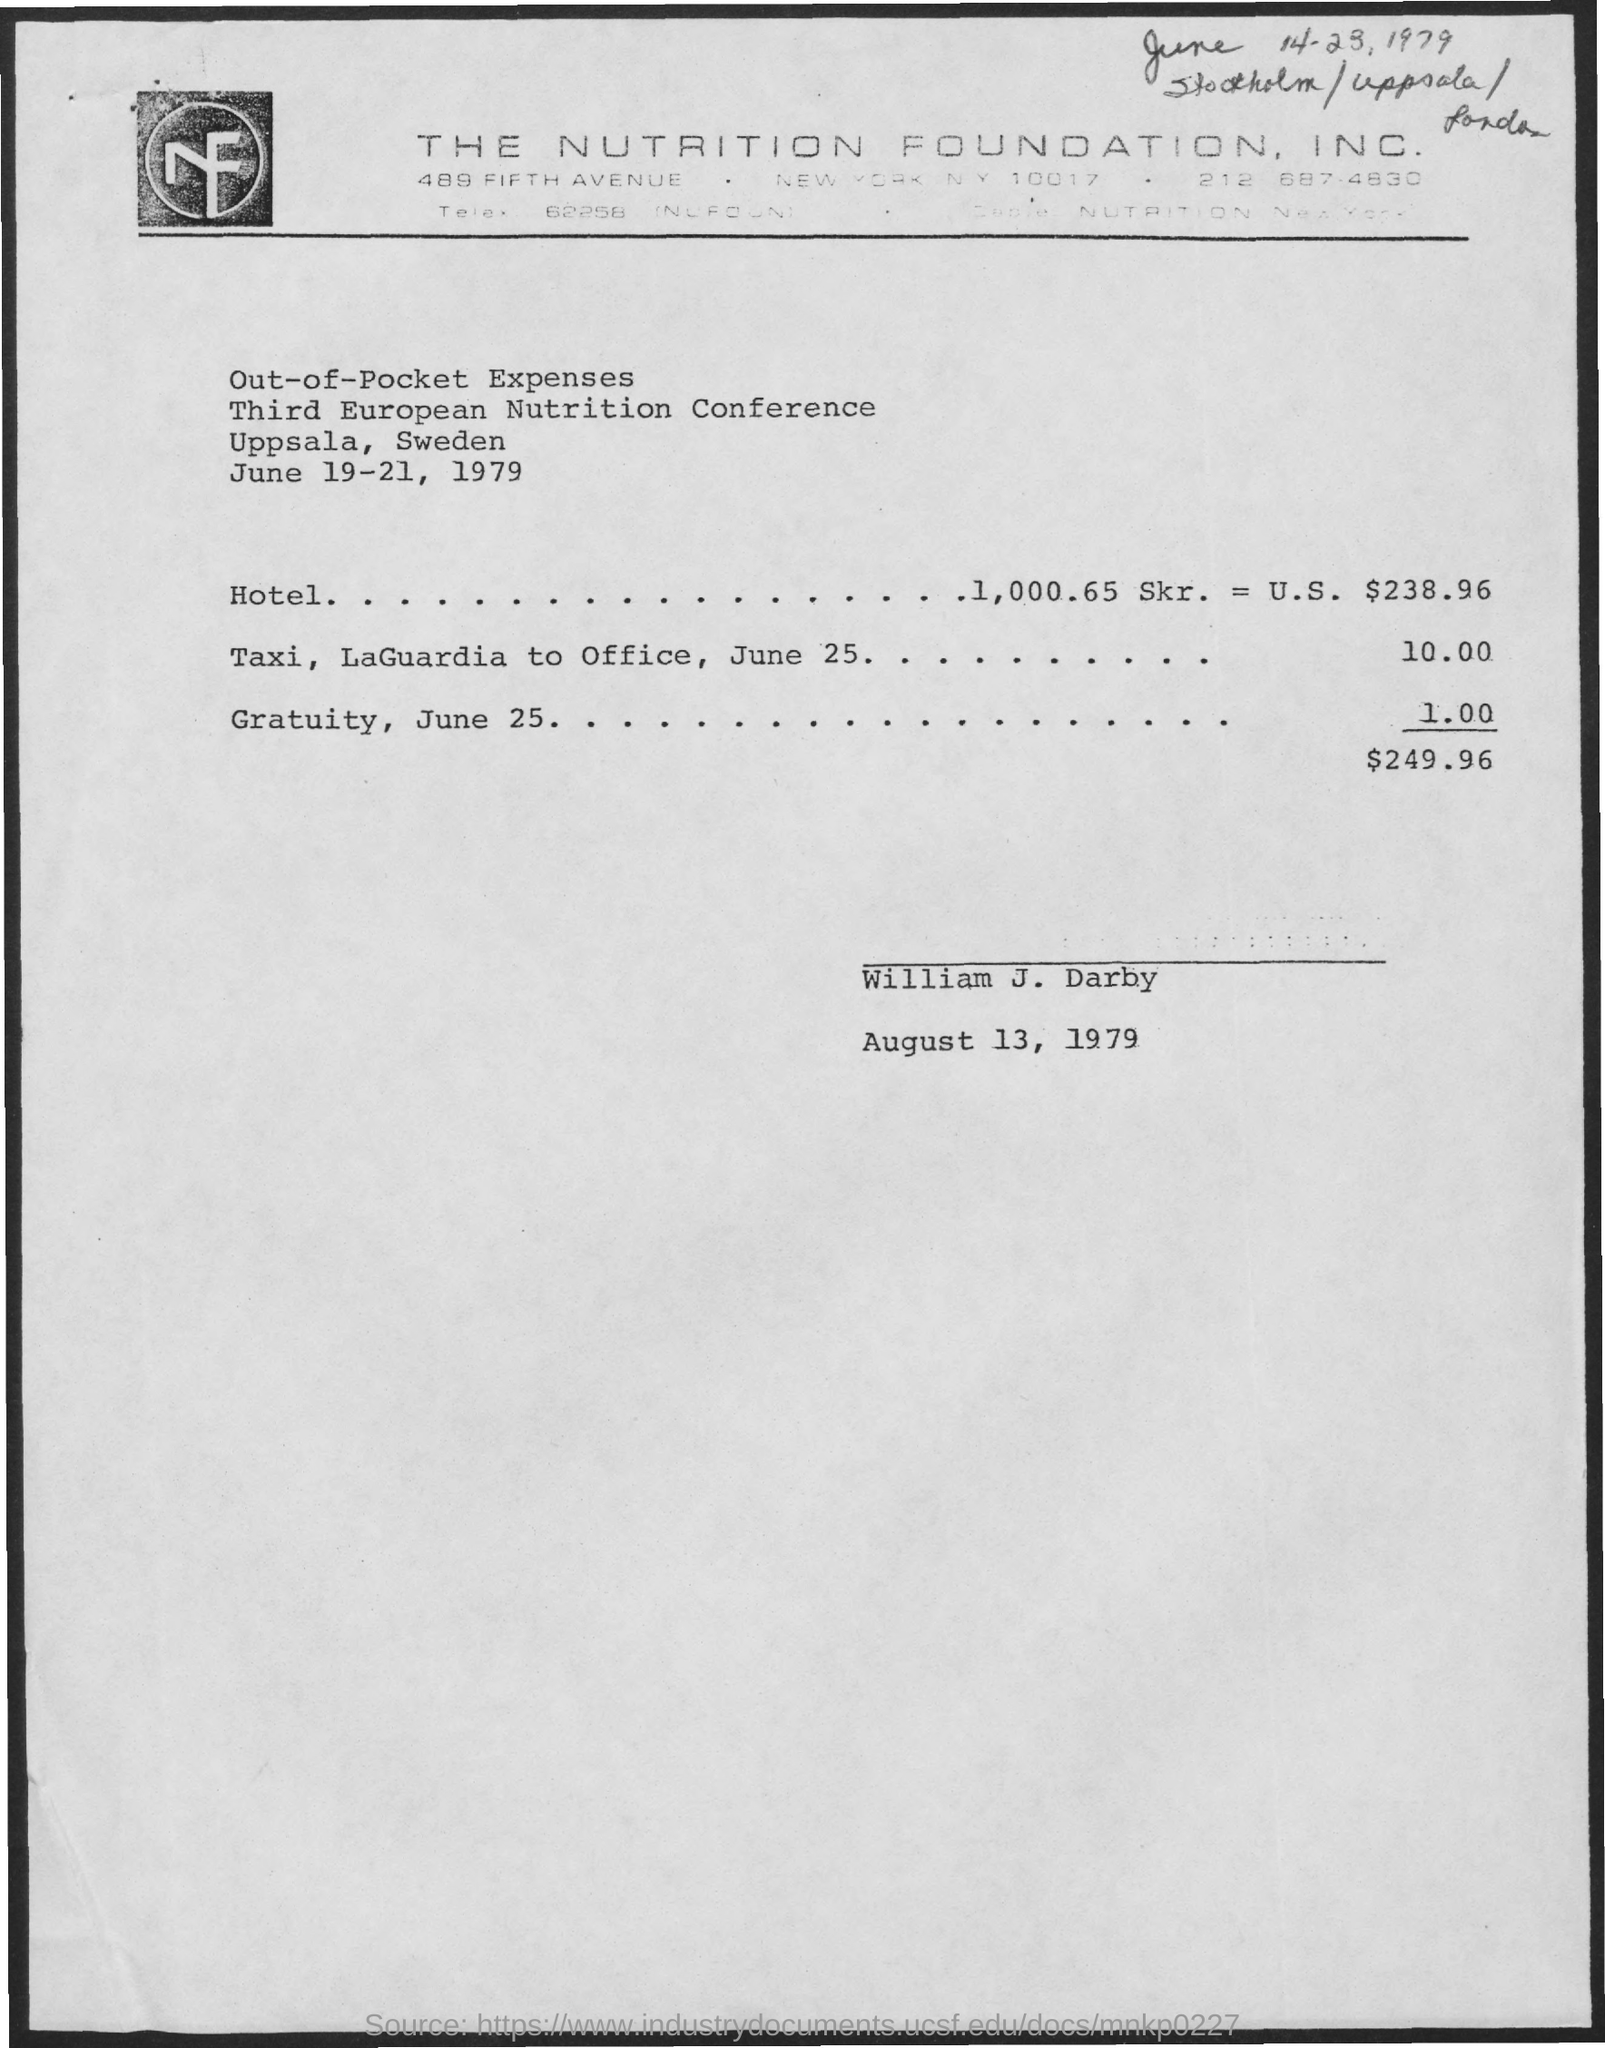Where is the conference?
Provide a succinct answer. Uppsala, sweden. When is the conference?
Ensure brevity in your answer.  June 19-21, 1979. 